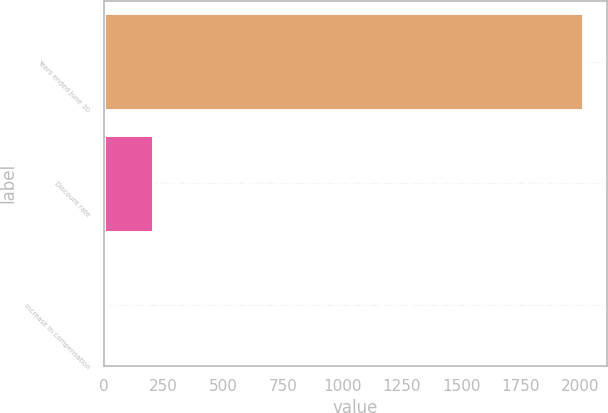<chart> <loc_0><loc_0><loc_500><loc_500><bar_chart><fcel>Years ended June 30<fcel>Discount rate<fcel>Increase in compensation<nl><fcel>2009<fcel>205.85<fcel>5.5<nl></chart> 